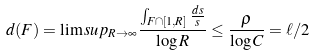<formula> <loc_0><loc_0><loc_500><loc_500>d ( F ) = \lim s u p _ { R \to \infty } \frac { \int _ { F \cap [ 1 , R ] } \frac { d s } { s } } { \log R } \leq \frac { \rho } { \log C } = \ell / 2</formula> 